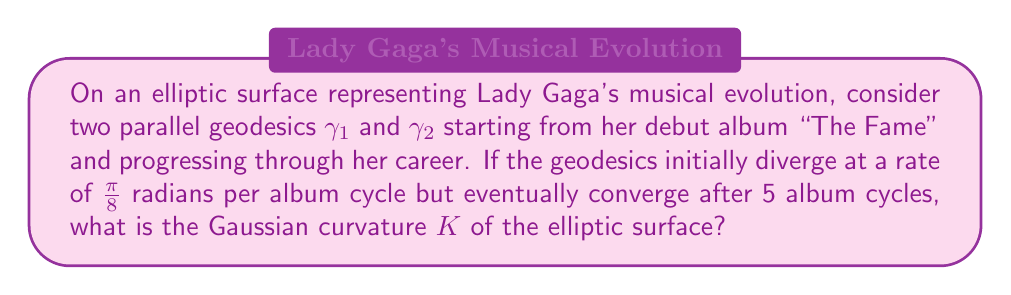Could you help me with this problem? Let's approach this step-by-step:

1) In elliptic geometry, parallel lines (geodesics) initially diverge but eventually converge, much like Lady Gaga's musical style evolving and coming full circle.

2) The behavior of parallel geodesics on a surface of constant curvature is described by the equation:

   $$\theta(s) = \frac{\pi}{2} - 2 \tan^{-1}(e^{-s\sqrt{K}})$$

   where $\theta(s)$ is the angle between the geodesics at distance $s$, and $K$ is the Gaussian curvature.

3) We're told that the geodesics initially diverge at a rate of $\frac{\pi}{8}$ radians per album cycle. This gives us:

   $$\frac{d\theta}{ds}|_{s=0} = \frac{\pi}{8}$$

4) Differentiating the equation in step 2 with respect to $s$ and evaluating at $s=0$:

   $$\frac{d\theta}{ds}|_{s=0} = \sqrt{K}$$

5) Equating this with our given rate:

   $$\sqrt{K} = \frac{\pi}{8}$$

6) The geodesics converge after 5 album cycles, meaning $\theta(5) = \pi$. Substituting this into our original equation:

   $$\pi = \frac{\pi}{2} - 2 \tan^{-1}(e^{-5\sqrt{K}})$$

7) Solving this equation:

   $$\tan^{-1}(e^{-5\sqrt{K}}) = -\frac{\pi}{4}$$
   $$e^{-5\sqrt{K}} = \tan(-\frac{\pi}{4}) = -1$$
   $$-5\sqrt{K} = \ln(-1) = \pi i$$
   $$\sqrt{K} = -\frac{\pi i}{5}$$

8) Comparing this with our result from step 5:

   $$\frac{\pi}{8} = -\frac{\pi i}{5}$$

9) Squaring both sides to get $K$:

   $$K = (\frac{\pi}{8})^2 = \frac{\pi^2}{64}$$
Answer: $K = \frac{\pi^2}{64}$ 